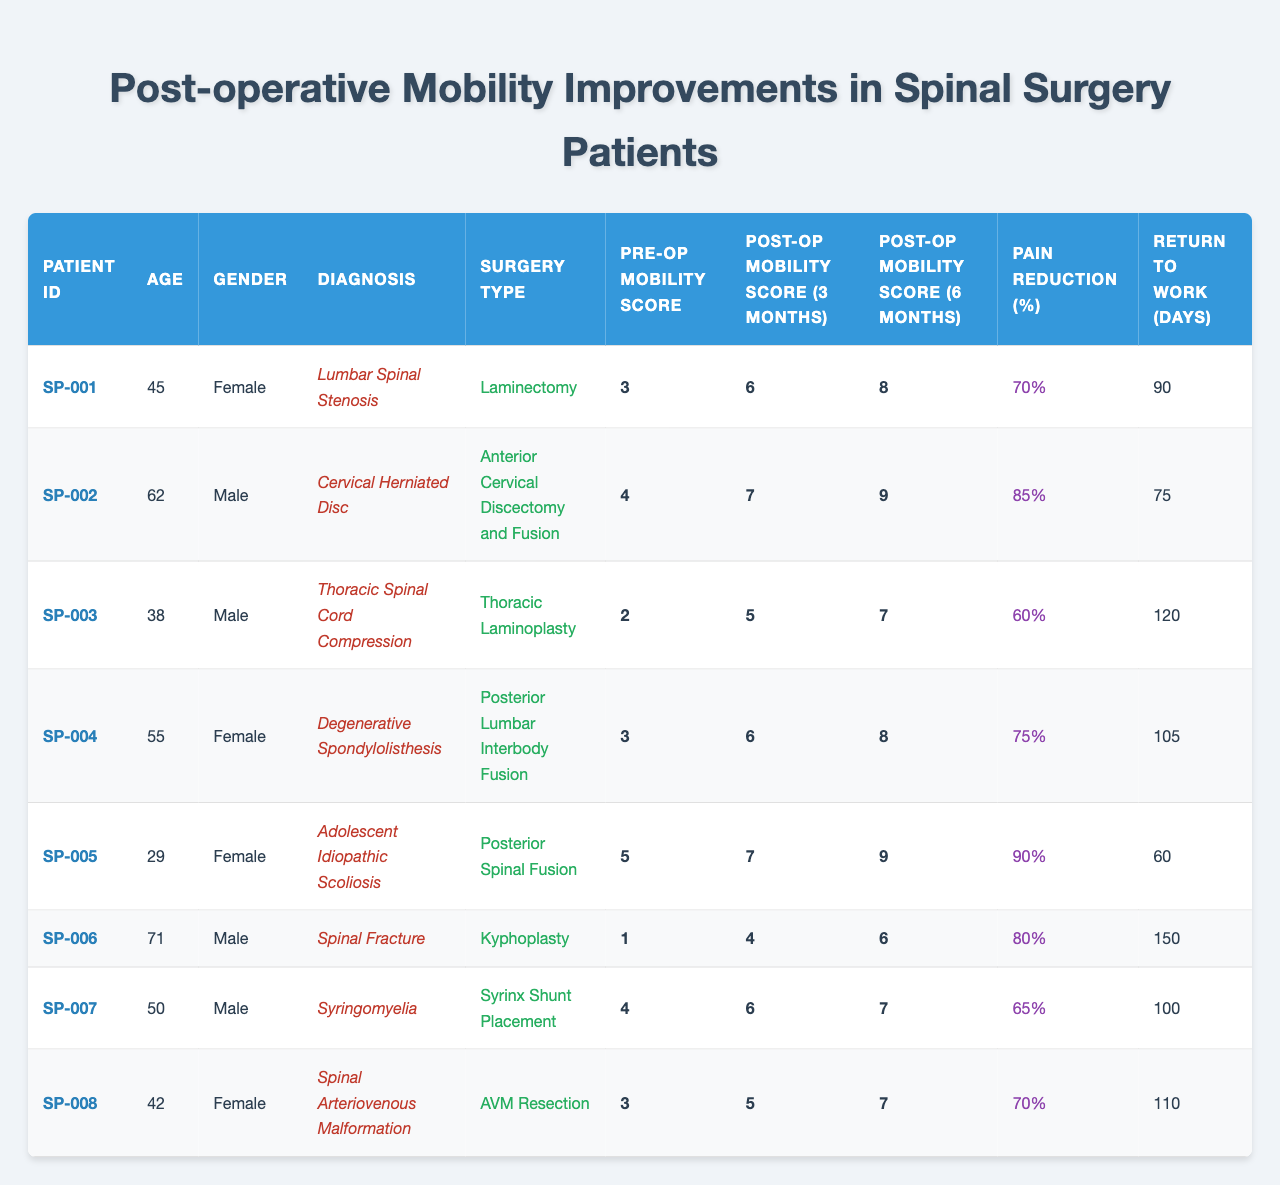What is the pre-operative mobility score of patient SP-005? The pre-operative mobility score for patient SP-005, who has Adolescent Idiopathic Scoliosis, is listed in the table. It states the score as 5.
Answer: 5 What is the pain reduction percentage for patient SP-002? The pain reduction percentage for patient SP-002, who underwent Anterior Cervical Discectomy and Fusion, is shown in the table as 85%.
Answer: 85% Who had the least pre-operative mobility score? The patients' pre-operative mobility scores are assessed, and patient SP-006, with a mobility score of 1, has the least score among all listed.
Answer: SP-006 What is the average post-operative mobility score at 3 months for all patients? The post-operative mobility scores at 3 months are 6, 7, 5, 6, 7, 4, 6, and 5. Summing these gives 46. There are 8 patients, so the average score is 46/8 = 5.75.
Answer: 5.75 Did any patient take more than 120 days to return to work? Comparing the return to work days for all patients shows that patient SP-006 took 150 days, which is more than 120 days.
Answer: Yes Which surgery type had the highest post-operative mobility score at 6 months? The post-operative mobility scores at 6 months for each surgery type show that patient SP-002’s score is 9, the highest among all.
Answer: Anterior Cervical Discectomy and Fusion What is the difference in pain reduction percentage between patient SP-001 and patient SP-004? Patient SP-001 has a pain reduction percentage of 70% and patient SP-004 has 75%. The difference is 75 - 70 = 5%.
Answer: 5% Which gender had more patients in this study? By counting the gender from all entries, there are 4 females (SP-001, SP-004, SP-005, SP-008) and 4 males (SP-002, SP-003, SP-006, SP-007), so the count is equal.
Answer: Neither What percentage of patients had a post-operative mobility score of 9 at 6 months? Only patient SP-002 and patient SP-005 had a score of 9 at 6 months, giving us 2 out of 8 patients. Therefore, the percentage is (2/8) * 100 = 25%.
Answer: 25% Which diagnosis had the highest pain reduction percentage and what was it? Upon examining the pain reduction percentages, patient SP-005 with Adolescent Idiopathic Scoliosis had the highest percentage at 90%.
Answer: Adolescent Idiopathic Scoliosis, 90% 